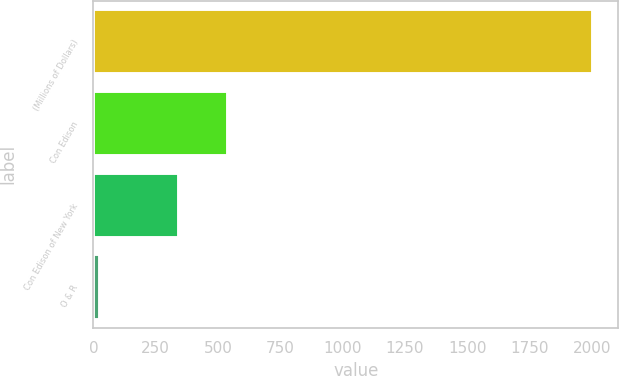Convert chart. <chart><loc_0><loc_0><loc_500><loc_500><bar_chart><fcel>(Millions of Dollars)<fcel>Con Edison<fcel>Con Edison of New York<fcel>O & R<nl><fcel>2006<fcel>542<fcel>344<fcel>26<nl></chart> 